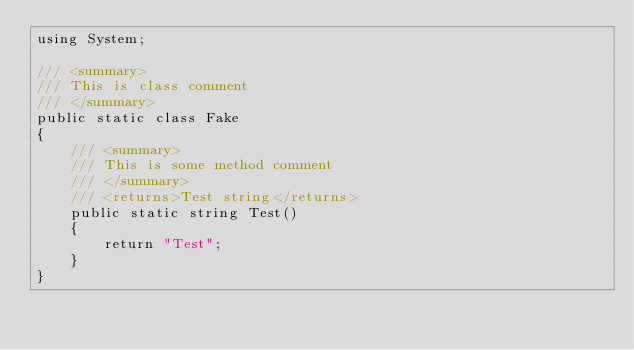Convert code to text. <code><loc_0><loc_0><loc_500><loc_500><_C#_>using System;
 
/// <summary>
/// This is class comment
/// </summary>
public static class Fake
{
    /// <summary>
    /// This is some method comment
    /// </summary>
    /// <returns>Test string</returns>
    public static string Test()
    {
        return "Test";
    }
}</code> 